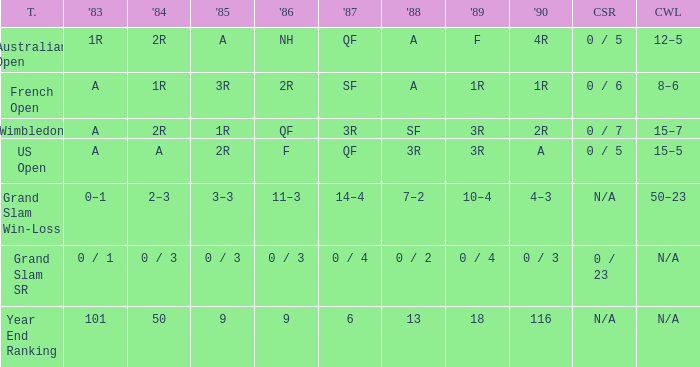In 1983 what is the tournament that is 0 / 1? Grand Slam SR. 